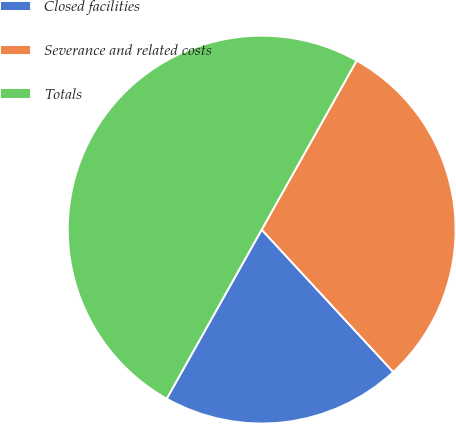Convert chart to OTSL. <chart><loc_0><loc_0><loc_500><loc_500><pie_chart><fcel>Closed facilities<fcel>Severance and related costs<fcel>Totals<nl><fcel>20.02%<fcel>29.98%<fcel>50.0%<nl></chart> 